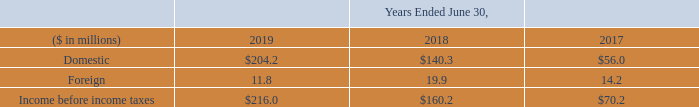17. Income Taxes
Income before income taxes for the Company’s domestic and foreign operations was as follows:
What was the amount of Income before income taxes in 2019?
Answer scale should be: million. $216.0. What was the amount of  Domestic  Income before income taxes in 2018?
Answer scale should be: million. $140.3. What are the different types of operations for which income before income taxes was provided? Domestic, foreign. In which year was Foreign largest? 19.9>14.2>11.8
Answer: 2018. What was the change in Foreign in 2019 from 2018?
Answer scale should be: million. 11.8-19.9
Answer: -8.1. What was the percentage change in Foreign in 2019 from 2018?
Answer scale should be: percent. (11.8-19.9)/19.9
Answer: -40.7. 